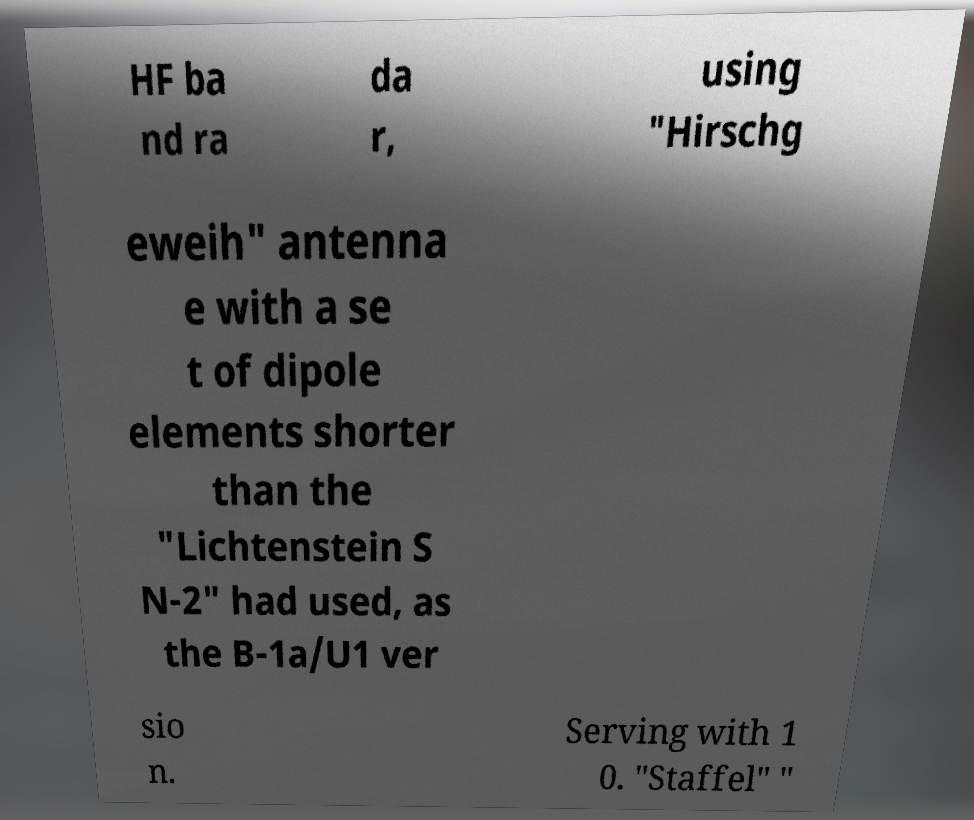What messages or text are displayed in this image? I need them in a readable, typed format. HF ba nd ra da r, using "Hirschg eweih" antenna e with a se t of dipole elements shorter than the "Lichtenstein S N-2" had used, as the B-1a/U1 ver sio n. Serving with 1 0. "Staffel" " 